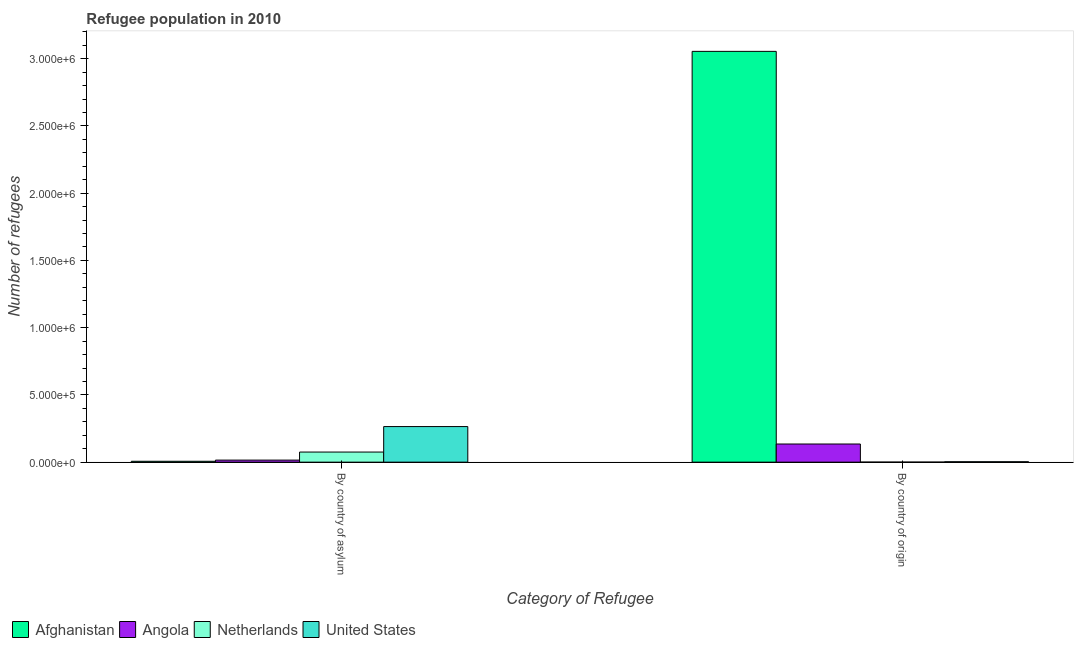How many different coloured bars are there?
Offer a terse response. 4. How many groups of bars are there?
Offer a terse response. 2. Are the number of bars on each tick of the X-axis equal?
Your answer should be compact. Yes. How many bars are there on the 1st tick from the left?
Keep it short and to the point. 4. What is the label of the 2nd group of bars from the left?
Keep it short and to the point. By country of origin. What is the number of refugees by country of asylum in United States?
Ensure brevity in your answer.  2.65e+05. Across all countries, what is the maximum number of refugees by country of origin?
Offer a terse response. 3.05e+06. Across all countries, what is the minimum number of refugees by country of origin?
Your answer should be very brief. 53. In which country was the number of refugees by country of origin maximum?
Provide a succinct answer. Afghanistan. What is the total number of refugees by country of origin in the graph?
Your answer should be very brief. 3.19e+06. What is the difference between the number of refugees by country of asylum in United States and that in Afghanistan?
Ensure brevity in your answer.  2.58e+05. What is the difference between the number of refugees by country of asylum in United States and the number of refugees by country of origin in Netherlands?
Your answer should be compact. 2.65e+05. What is the average number of refugees by country of origin per country?
Ensure brevity in your answer.  7.98e+05. What is the difference between the number of refugees by country of origin and number of refugees by country of asylum in United States?
Your response must be concise. -2.62e+05. What is the ratio of the number of refugees by country of asylum in Angola to that in United States?
Your answer should be compact. 0.06. What does the 2nd bar from the left in By country of asylum represents?
Your response must be concise. Angola. What does the 4th bar from the right in By country of asylum represents?
Offer a very short reply. Afghanistan. How many bars are there?
Make the answer very short. 8. Are all the bars in the graph horizontal?
Make the answer very short. No. How many countries are there in the graph?
Your answer should be compact. 4. What is the title of the graph?
Give a very brief answer. Refugee population in 2010. What is the label or title of the X-axis?
Provide a succinct answer. Category of Refugee. What is the label or title of the Y-axis?
Give a very brief answer. Number of refugees. What is the Number of refugees in Afghanistan in By country of asylum?
Offer a terse response. 6434. What is the Number of refugees in Angola in By country of asylum?
Give a very brief answer. 1.52e+04. What is the Number of refugees of Netherlands in By country of asylum?
Your answer should be very brief. 7.50e+04. What is the Number of refugees in United States in By country of asylum?
Provide a succinct answer. 2.65e+05. What is the Number of refugees of Afghanistan in By country of origin?
Your answer should be very brief. 3.05e+06. What is the Number of refugees in Angola in By country of origin?
Ensure brevity in your answer.  1.35e+05. What is the Number of refugees in United States in By country of origin?
Give a very brief answer. 3026. Across all Category of Refugee, what is the maximum Number of refugees of Afghanistan?
Offer a terse response. 3.05e+06. Across all Category of Refugee, what is the maximum Number of refugees of Angola?
Give a very brief answer. 1.35e+05. Across all Category of Refugee, what is the maximum Number of refugees in Netherlands?
Keep it short and to the point. 7.50e+04. Across all Category of Refugee, what is the maximum Number of refugees in United States?
Offer a very short reply. 2.65e+05. Across all Category of Refugee, what is the minimum Number of refugees in Afghanistan?
Ensure brevity in your answer.  6434. Across all Category of Refugee, what is the minimum Number of refugees in Angola?
Your answer should be compact. 1.52e+04. Across all Category of Refugee, what is the minimum Number of refugees of Netherlands?
Provide a short and direct response. 53. Across all Category of Refugee, what is the minimum Number of refugees in United States?
Ensure brevity in your answer.  3026. What is the total Number of refugees of Afghanistan in the graph?
Your answer should be very brief. 3.06e+06. What is the total Number of refugees of Angola in the graph?
Offer a very short reply. 1.50e+05. What is the total Number of refugees in Netherlands in the graph?
Keep it short and to the point. 7.50e+04. What is the total Number of refugees in United States in the graph?
Give a very brief answer. 2.68e+05. What is the difference between the Number of refugees in Afghanistan in By country of asylum and that in By country of origin?
Your answer should be very brief. -3.05e+06. What is the difference between the Number of refugees in Angola in By country of asylum and that in By country of origin?
Offer a terse response. -1.20e+05. What is the difference between the Number of refugees of Netherlands in By country of asylum and that in By country of origin?
Make the answer very short. 7.49e+04. What is the difference between the Number of refugees of United States in By country of asylum and that in By country of origin?
Provide a succinct answer. 2.62e+05. What is the difference between the Number of refugees in Afghanistan in By country of asylum and the Number of refugees in Angola in By country of origin?
Your response must be concise. -1.28e+05. What is the difference between the Number of refugees of Afghanistan in By country of asylum and the Number of refugees of Netherlands in By country of origin?
Give a very brief answer. 6381. What is the difference between the Number of refugees in Afghanistan in By country of asylum and the Number of refugees in United States in By country of origin?
Offer a terse response. 3408. What is the difference between the Number of refugees in Angola in By country of asylum and the Number of refugees in Netherlands in By country of origin?
Your answer should be compact. 1.51e+04. What is the difference between the Number of refugees in Angola in By country of asylum and the Number of refugees in United States in By country of origin?
Your response must be concise. 1.21e+04. What is the difference between the Number of refugees in Netherlands in By country of asylum and the Number of refugees in United States in By country of origin?
Your response must be concise. 7.19e+04. What is the average Number of refugees of Afghanistan per Category of Refugee?
Give a very brief answer. 1.53e+06. What is the average Number of refugees in Angola per Category of Refugee?
Your answer should be very brief. 7.50e+04. What is the average Number of refugees in Netherlands per Category of Refugee?
Your answer should be very brief. 3.75e+04. What is the average Number of refugees in United States per Category of Refugee?
Offer a terse response. 1.34e+05. What is the difference between the Number of refugees in Afghanistan and Number of refugees in Angola in By country of asylum?
Keep it short and to the point. -8721. What is the difference between the Number of refugees in Afghanistan and Number of refugees in Netherlands in By country of asylum?
Ensure brevity in your answer.  -6.85e+04. What is the difference between the Number of refugees of Afghanistan and Number of refugees of United States in By country of asylum?
Keep it short and to the point. -2.58e+05. What is the difference between the Number of refugees of Angola and Number of refugees of Netherlands in By country of asylum?
Ensure brevity in your answer.  -5.98e+04. What is the difference between the Number of refugees in Angola and Number of refugees in United States in By country of asylum?
Your response must be concise. -2.49e+05. What is the difference between the Number of refugees of Netherlands and Number of refugees of United States in By country of asylum?
Make the answer very short. -1.90e+05. What is the difference between the Number of refugees of Afghanistan and Number of refugees of Angola in By country of origin?
Your response must be concise. 2.92e+06. What is the difference between the Number of refugees of Afghanistan and Number of refugees of Netherlands in By country of origin?
Your response must be concise. 3.05e+06. What is the difference between the Number of refugees in Afghanistan and Number of refugees in United States in By country of origin?
Keep it short and to the point. 3.05e+06. What is the difference between the Number of refugees of Angola and Number of refugees of Netherlands in By country of origin?
Provide a short and direct response. 1.35e+05. What is the difference between the Number of refugees in Angola and Number of refugees in United States in By country of origin?
Offer a very short reply. 1.32e+05. What is the difference between the Number of refugees of Netherlands and Number of refugees of United States in By country of origin?
Your answer should be very brief. -2973. What is the ratio of the Number of refugees of Afghanistan in By country of asylum to that in By country of origin?
Provide a short and direct response. 0. What is the ratio of the Number of refugees in Angola in By country of asylum to that in By country of origin?
Your response must be concise. 0.11. What is the ratio of the Number of refugees of Netherlands in By country of asylum to that in By country of origin?
Your answer should be very brief. 1414.36. What is the ratio of the Number of refugees of United States in By country of asylum to that in By country of origin?
Ensure brevity in your answer.  87.43. What is the difference between the highest and the second highest Number of refugees of Afghanistan?
Offer a very short reply. 3.05e+06. What is the difference between the highest and the second highest Number of refugees of Angola?
Give a very brief answer. 1.20e+05. What is the difference between the highest and the second highest Number of refugees of Netherlands?
Ensure brevity in your answer.  7.49e+04. What is the difference between the highest and the second highest Number of refugees of United States?
Your answer should be compact. 2.62e+05. What is the difference between the highest and the lowest Number of refugees of Afghanistan?
Provide a succinct answer. 3.05e+06. What is the difference between the highest and the lowest Number of refugees of Angola?
Offer a very short reply. 1.20e+05. What is the difference between the highest and the lowest Number of refugees in Netherlands?
Make the answer very short. 7.49e+04. What is the difference between the highest and the lowest Number of refugees of United States?
Your response must be concise. 2.62e+05. 